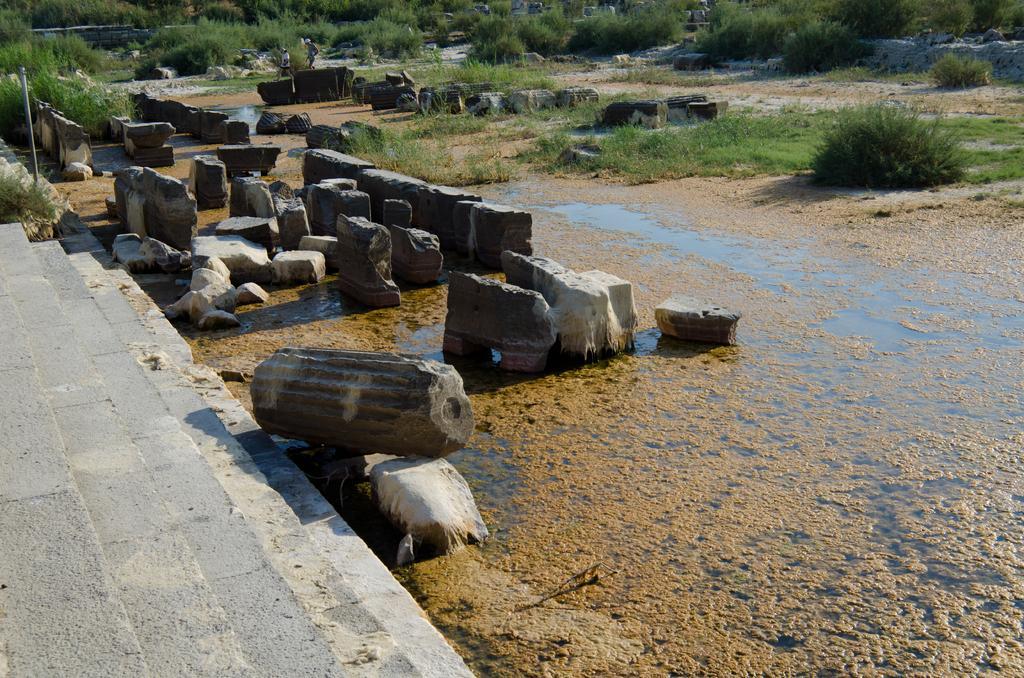How would you summarize this image in a sentence or two? In the center of the image we can see a group of rocks. To the left side of the image we can see staircase. In the background, we can see group of plants. Two persons standing on the ground. 